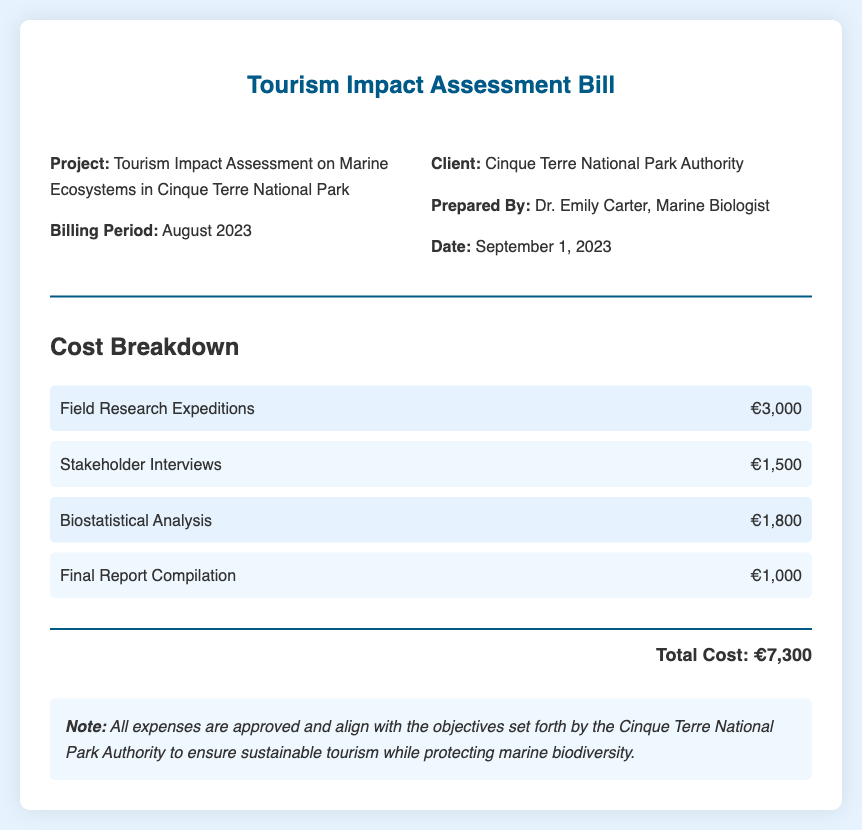what is the total cost? The total cost is listed at the bottom of the document, summarizing all expenses incurred during the tourism impact assessment.
Answer: €7,300 who prepared the bill? The document mentions the individual responsible for preparing the bill, who is a marine biologist.
Answer: Dr. Emily Carter what is the date of the bill? The bill states the date it was prepared, which is important for record-keeping.
Answer: September 1, 2023 how much did the field research expeditions cost? The cost breakdown includes a specific amount for field research expeditions, which is a key expense in the project.
Answer: €3,000 what is the billing period? The billing period indicates the timeframe during which the services were rendered.
Answer: August 2023 how much was spent on stakeholder interviews? The document allows us to identify the cost associated with stakeholder interviews, which is relevant for assessing engagement.
Answer: €1,500 what is included in the final report compilation cost? The final report compilation cost reflects the expense incurred for compiling and presenting the findings of the assessment.
Answer: €1,000 why are the expenses approved? The document states the approval of all expenses and their alignment with project objectives, indicating a structured financial process.
Answer: Ensure sustainable tourism while protecting marine biodiversity 